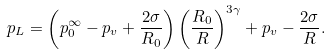Convert formula to latex. <formula><loc_0><loc_0><loc_500><loc_500>p _ { L } = \left ( p _ { 0 } ^ { \infty } - p _ { v } + \frac { 2 \sigma } { R _ { 0 } } \right ) \left ( \frac { R _ { 0 } } { R } \right ) ^ { 3 \gamma } + p _ { v } - \frac { 2 \sigma } { R } .</formula> 